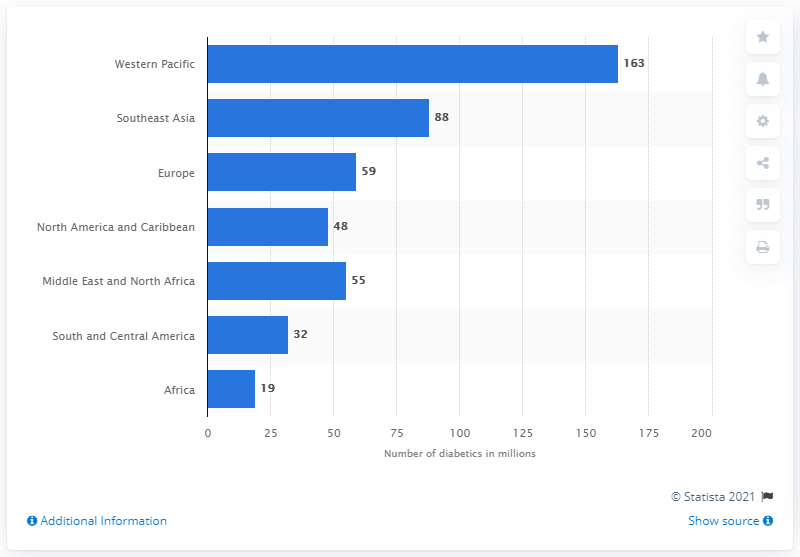Mention a couple of crucial points in this snapshot. In the Western Pacific, an estimated 163 million people between the ages of 20 and 79 suffer from diabetes. 